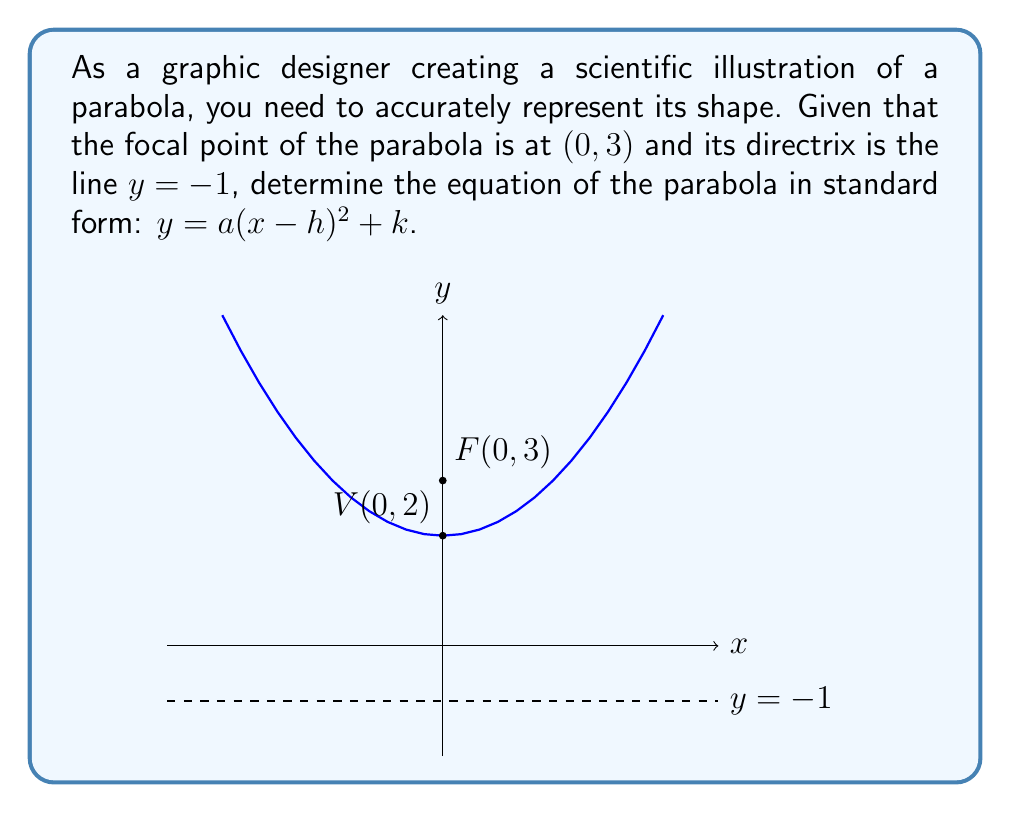Provide a solution to this math problem. To determine the equation of the parabola, we'll follow these steps:

1) The general equation of a parabola with a vertical axis of symmetry is:
   $y = a(x-h)^2 + k$
   where $(h,k)$ is the vertex of the parabola.

2) The distance from the focal point to the directrix is called the focal length, $p$. We can calculate this:
   $p = \frac{1}{2}$(distance from focal point to directrix)
   $p = \frac{1}{2}(3 - (-1)) = \frac{1}{2}(4) = 2$

3) The vertex of the parabola is always halfway between the focal point and the directrix:
   $k = 3 - 2 = 1$, or $k = -1 + 2 = 1$
   So the y-coordinate of the vertex is 1.

4) Since the focal point is on the y-axis, the parabola is symmetric about the y-axis, so $h = 0$.

5) For a parabola with a vertical axis of symmetry, $a = \frac{1}{4p}$. Therefore:
   $a = \frac{1}{4(2)} = \frac{1}{8}$

6) Now we can substitute these values into our general equation:
   $y = \frac{1}{8}(x-0)^2 + 1$

7) Simplifying:
   $y = \frac{1}{8}x^2 + 1$

This is the equation of the parabola in standard form.
Answer: $y = \frac{1}{8}x^2 + 1$ 